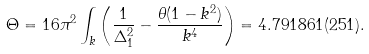<formula> <loc_0><loc_0><loc_500><loc_500>\Theta = 1 6 \pi ^ { 2 } \int _ { k } \left ( \frac { 1 } { \Delta ^ { 2 } _ { 1 } } - \frac { \theta ( 1 - k ^ { 2 } ) } { k ^ { 4 } } \right ) = 4 . 7 9 1 8 6 1 ( 2 5 1 ) .</formula> 